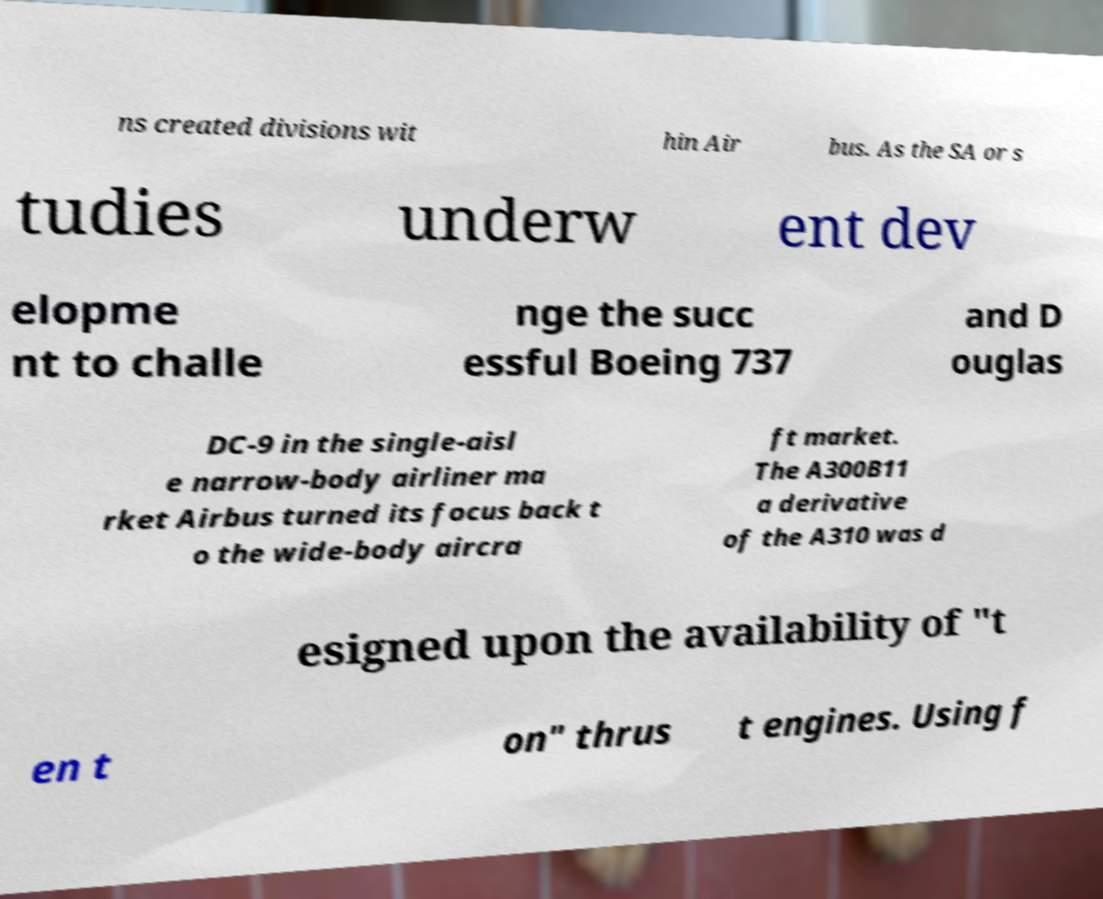Could you extract and type out the text from this image? ns created divisions wit hin Air bus. As the SA or s tudies underw ent dev elopme nt to challe nge the succ essful Boeing 737 and D ouglas DC-9 in the single-aisl e narrow-body airliner ma rket Airbus turned its focus back t o the wide-body aircra ft market. The A300B11 a derivative of the A310 was d esigned upon the availability of "t en t on" thrus t engines. Using f 